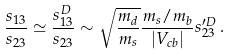Convert formula to latex. <formula><loc_0><loc_0><loc_500><loc_500>\frac { s _ { 1 3 } } { s _ { 2 3 } } \simeq \frac { s ^ { D } _ { 1 3 } } { s _ { 2 3 } } \sim \sqrt { \frac { m _ { d } } { m _ { s } } } \frac { m _ { s } / m _ { b } } { | V _ { c b } | } s ^ { \prime D } _ { 2 3 } \, .</formula> 